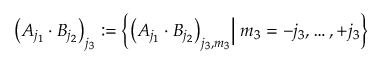<formula> <loc_0><loc_0><loc_500><loc_500>\Big ( A _ { j _ { 1 } } \cdot B _ { j _ { 2 } } \Big ) _ { j _ { 3 } } \colon = \left \{ \Big ( A _ { j _ { 1 } } \cdot B _ { j _ { 2 } } \Big ) _ { j _ { 3 } , m _ { 3 } } \Big | \, m _ { 3 } = - j _ { 3 } , \dots , + j _ { 3 } \right \}</formula> 